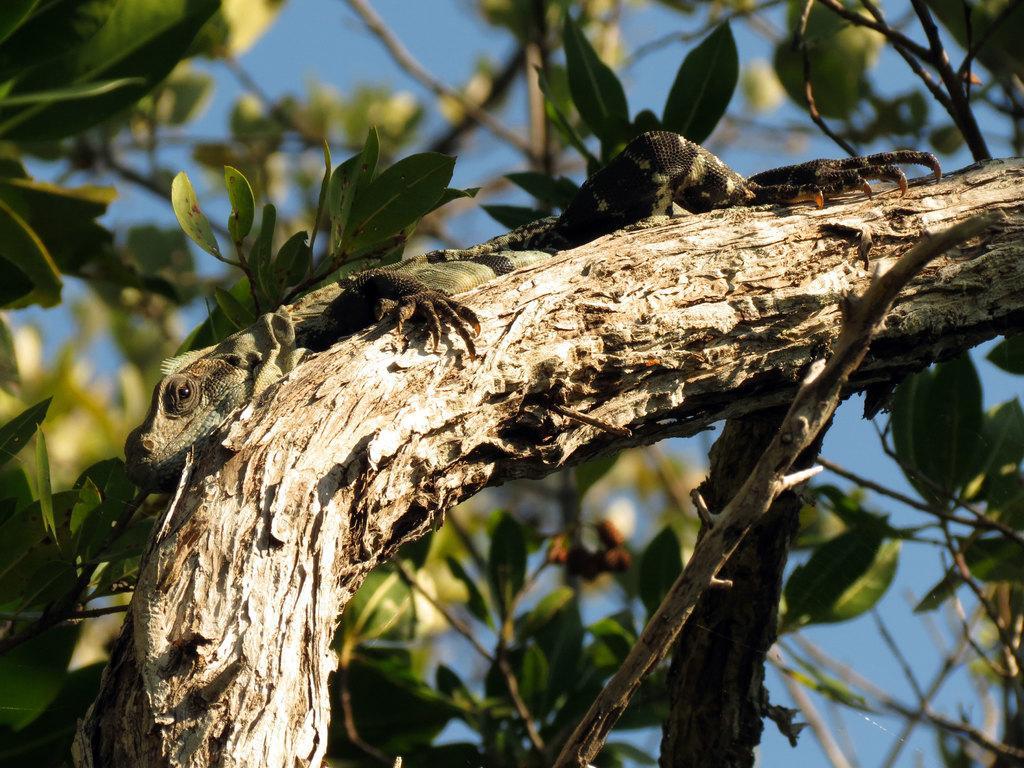Can you describe this image briefly? In this image, we can see chameleon on the tree branch. In the background, there are so many leaves, stems and the sky. 